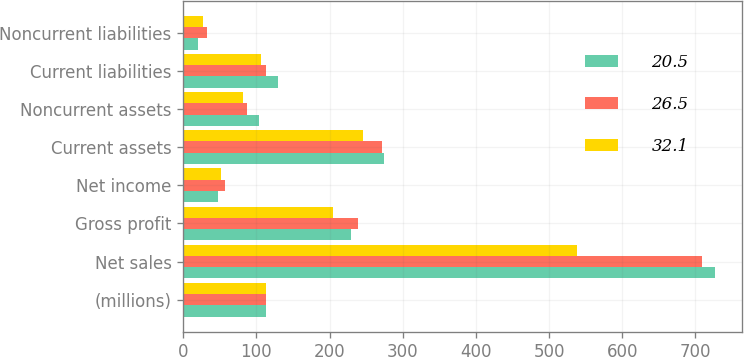Convert chart. <chart><loc_0><loc_0><loc_500><loc_500><stacked_bar_chart><ecel><fcel>(millions)<fcel>Net sales<fcel>Gross profit<fcel>Net income<fcel>Current assets<fcel>Noncurrent assets<fcel>Current liabilities<fcel>Noncurrent liabilities<nl><fcel>20.5<fcel>113.2<fcel>727.1<fcel>229.2<fcel>47.1<fcel>274.4<fcel>104.2<fcel>129.9<fcel>20.5<nl><fcel>26.5<fcel>113.2<fcel>708.5<fcel>238.7<fcel>57.2<fcel>272<fcel>86.5<fcel>113.2<fcel>32.1<nl><fcel>32.1<fcel>113.2<fcel>538.3<fcel>205.2<fcel>51.6<fcel>245.2<fcel>81.5<fcel>105.9<fcel>26.5<nl></chart> 